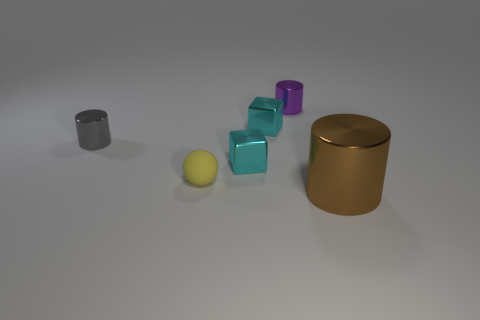Can you estimate the size relationships among the objects in the picture? Certainly, the large golden cylinder is the biggest object present. The purple and teal cubes appear to be similar in size, likely small enough to be comfortably held in one hand. The gray and silver cylinders are about half the height of the golden cylinder, and the brown cubes are the smallest objects, discernibly smaller than the other items. 